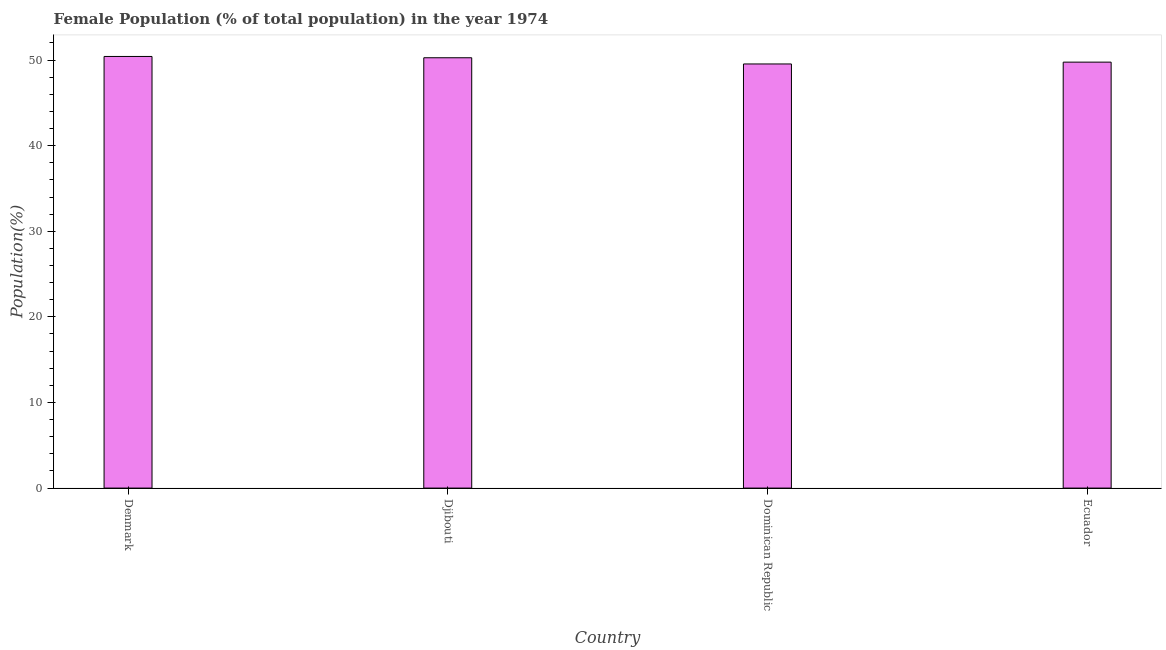Does the graph contain any zero values?
Give a very brief answer. No. What is the title of the graph?
Your answer should be very brief. Female Population (% of total population) in the year 1974. What is the label or title of the Y-axis?
Keep it short and to the point. Population(%). What is the female population in Dominican Republic?
Your answer should be very brief. 49.54. Across all countries, what is the maximum female population?
Your answer should be compact. 50.42. Across all countries, what is the minimum female population?
Keep it short and to the point. 49.54. In which country was the female population maximum?
Your response must be concise. Denmark. In which country was the female population minimum?
Your answer should be compact. Dominican Republic. What is the sum of the female population?
Keep it short and to the point. 199.98. What is the difference between the female population in Denmark and Djibouti?
Your answer should be very brief. 0.15. What is the average female population per country?
Your answer should be very brief. 49.99. What is the median female population?
Provide a short and direct response. 50.01. What is the difference between the highest and the second highest female population?
Your response must be concise. 0.15. In how many countries, is the female population greater than the average female population taken over all countries?
Give a very brief answer. 2. Are all the bars in the graph horizontal?
Provide a succinct answer. No. Are the values on the major ticks of Y-axis written in scientific E-notation?
Give a very brief answer. No. What is the Population(%) of Denmark?
Provide a short and direct response. 50.42. What is the Population(%) of Djibouti?
Give a very brief answer. 50.27. What is the Population(%) in Dominican Republic?
Offer a terse response. 49.54. What is the Population(%) in Ecuador?
Offer a terse response. 49.75. What is the difference between the Population(%) in Denmark and Djibouti?
Your answer should be very brief. 0.15. What is the difference between the Population(%) in Denmark and Dominican Republic?
Your response must be concise. 0.88. What is the difference between the Population(%) in Denmark and Ecuador?
Make the answer very short. 0.66. What is the difference between the Population(%) in Djibouti and Dominican Republic?
Keep it short and to the point. 0.72. What is the difference between the Population(%) in Djibouti and Ecuador?
Give a very brief answer. 0.51. What is the difference between the Population(%) in Dominican Republic and Ecuador?
Give a very brief answer. -0.21. What is the ratio of the Population(%) in Denmark to that in Djibouti?
Keep it short and to the point. 1. What is the ratio of the Population(%) in Denmark to that in Dominican Republic?
Keep it short and to the point. 1.02. What is the ratio of the Population(%) in Denmark to that in Ecuador?
Offer a terse response. 1.01. What is the ratio of the Population(%) in Djibouti to that in Dominican Republic?
Provide a succinct answer. 1.01. What is the ratio of the Population(%) in Djibouti to that in Ecuador?
Provide a short and direct response. 1.01. What is the ratio of the Population(%) in Dominican Republic to that in Ecuador?
Your answer should be very brief. 1. 